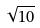<formula> <loc_0><loc_0><loc_500><loc_500>\sqrt { 1 0 }</formula> 